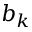Convert formula to latex. <formula><loc_0><loc_0><loc_500><loc_500>b _ { k }</formula> 